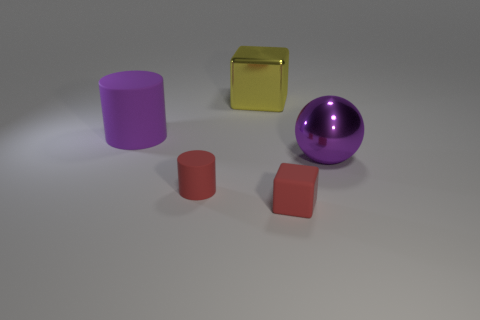Add 1 metal things. How many objects exist? 6 Subtract all blocks. How many objects are left? 3 Add 3 purple spheres. How many purple spheres are left? 4 Add 1 big yellow blocks. How many big yellow blocks exist? 2 Subtract 0 yellow cylinders. How many objects are left? 5 Subtract all green metal spheres. Subtract all purple shiny balls. How many objects are left? 4 